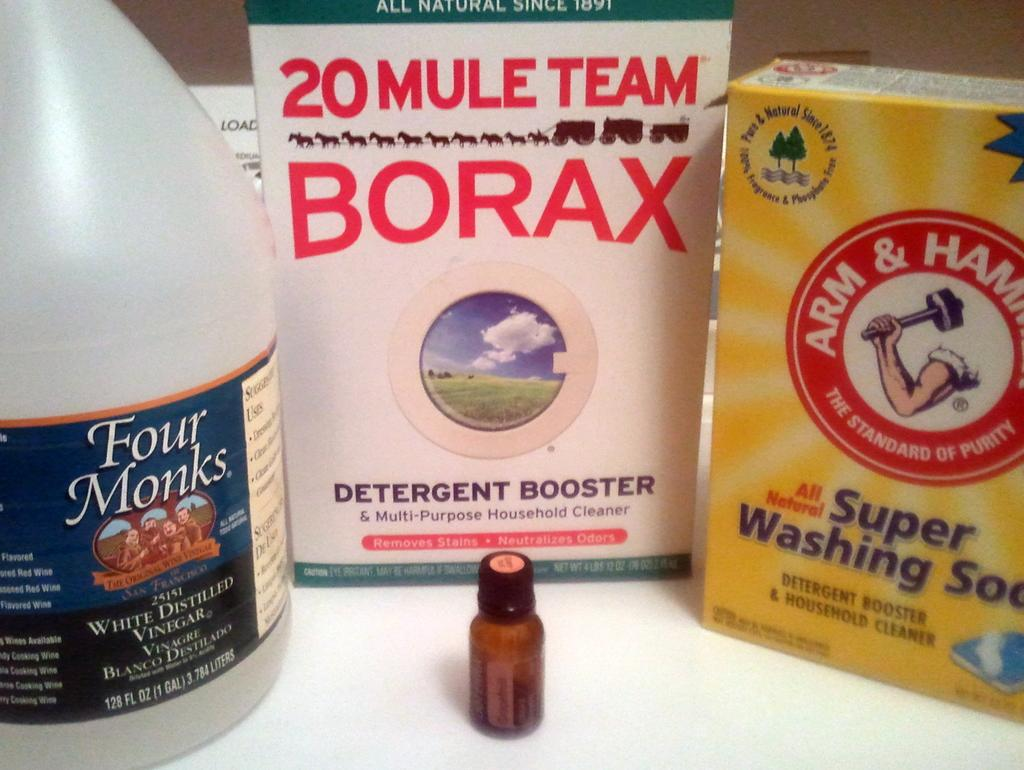<image>
Provide a brief description of the given image. several laundry supplies including borax and arm and hammer 